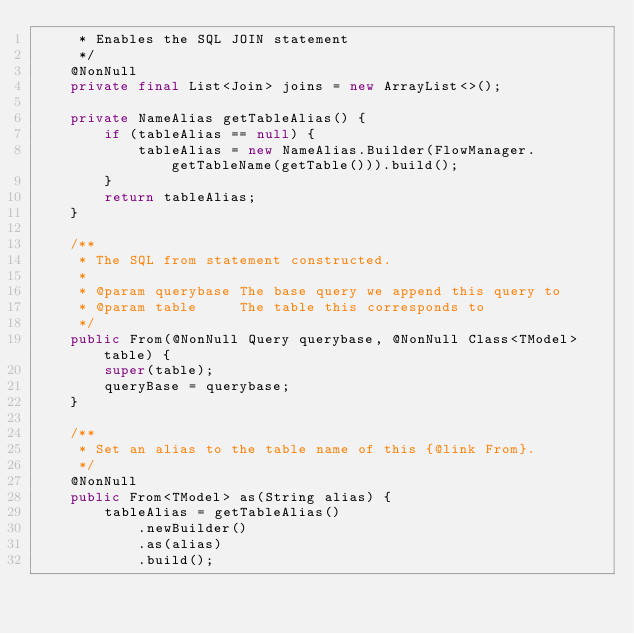Convert code to text. <code><loc_0><loc_0><loc_500><loc_500><_Java_>     * Enables the SQL JOIN statement
     */
    @NonNull
    private final List<Join> joins = new ArrayList<>();

    private NameAlias getTableAlias() {
        if (tableAlias == null) {
            tableAlias = new NameAlias.Builder(FlowManager.getTableName(getTable())).build();
        }
        return tableAlias;
    }

    /**
     * The SQL from statement constructed.
     *
     * @param querybase The base query we append this query to
     * @param table     The table this corresponds to
     */
    public From(@NonNull Query querybase, @NonNull Class<TModel> table) {
        super(table);
        queryBase = querybase;
    }

    /**
     * Set an alias to the table name of this {@link From}.
     */
    @NonNull
    public From<TModel> as(String alias) {
        tableAlias = getTableAlias()
            .newBuilder()
            .as(alias)
            .build();</code> 